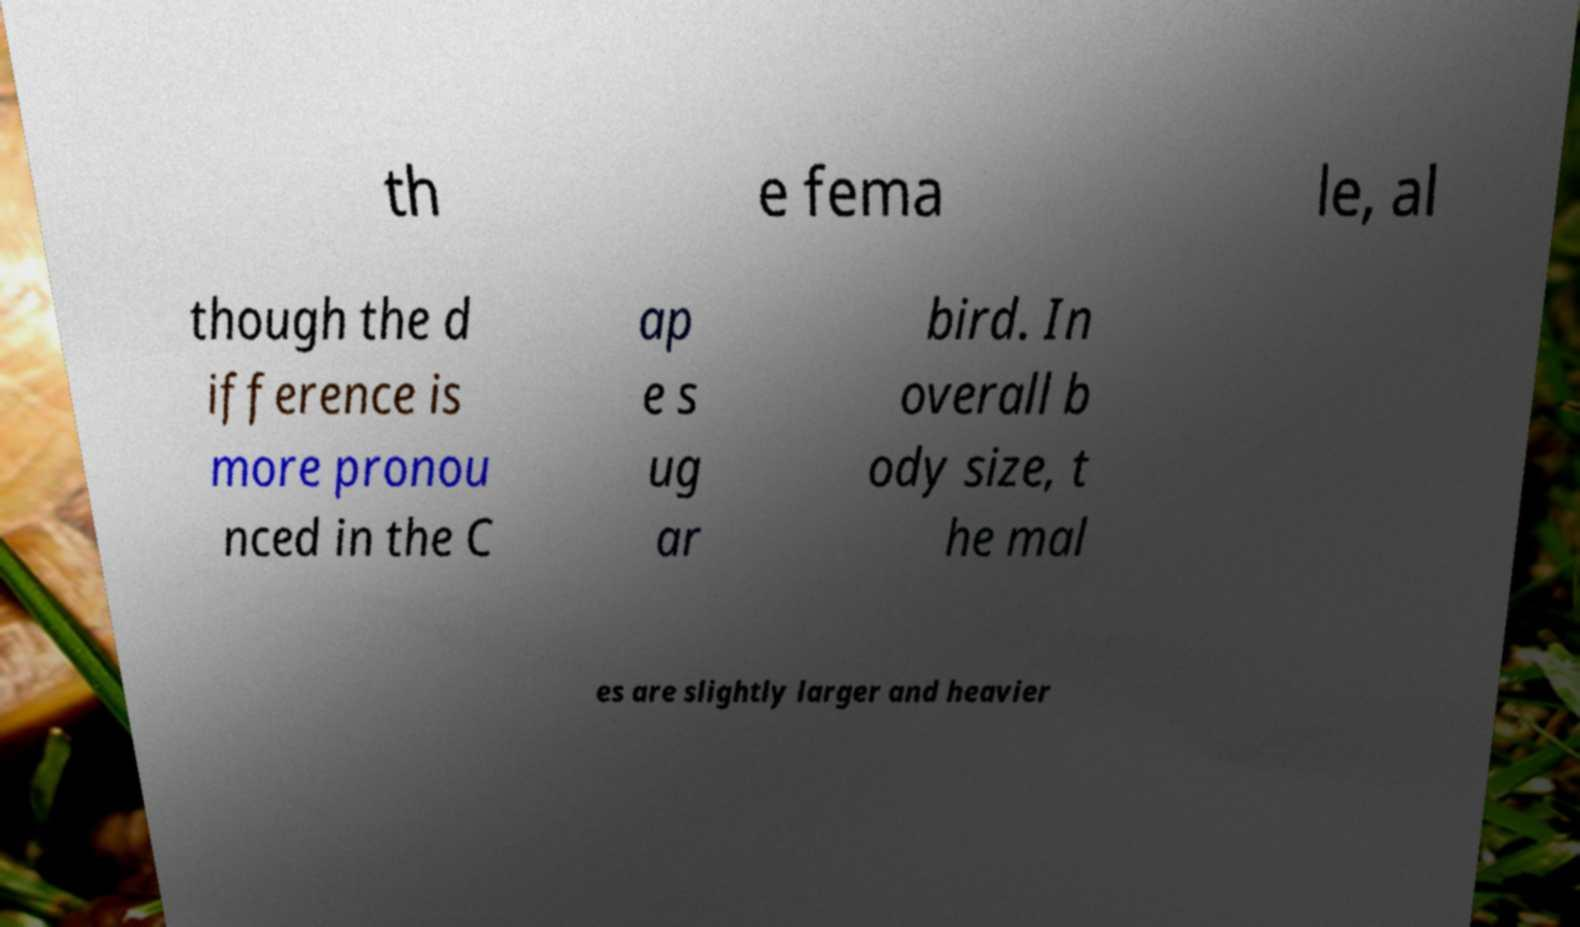Please identify and transcribe the text found in this image. th e fema le, al though the d ifference is more pronou nced in the C ap e s ug ar bird. In overall b ody size, t he mal es are slightly larger and heavier 